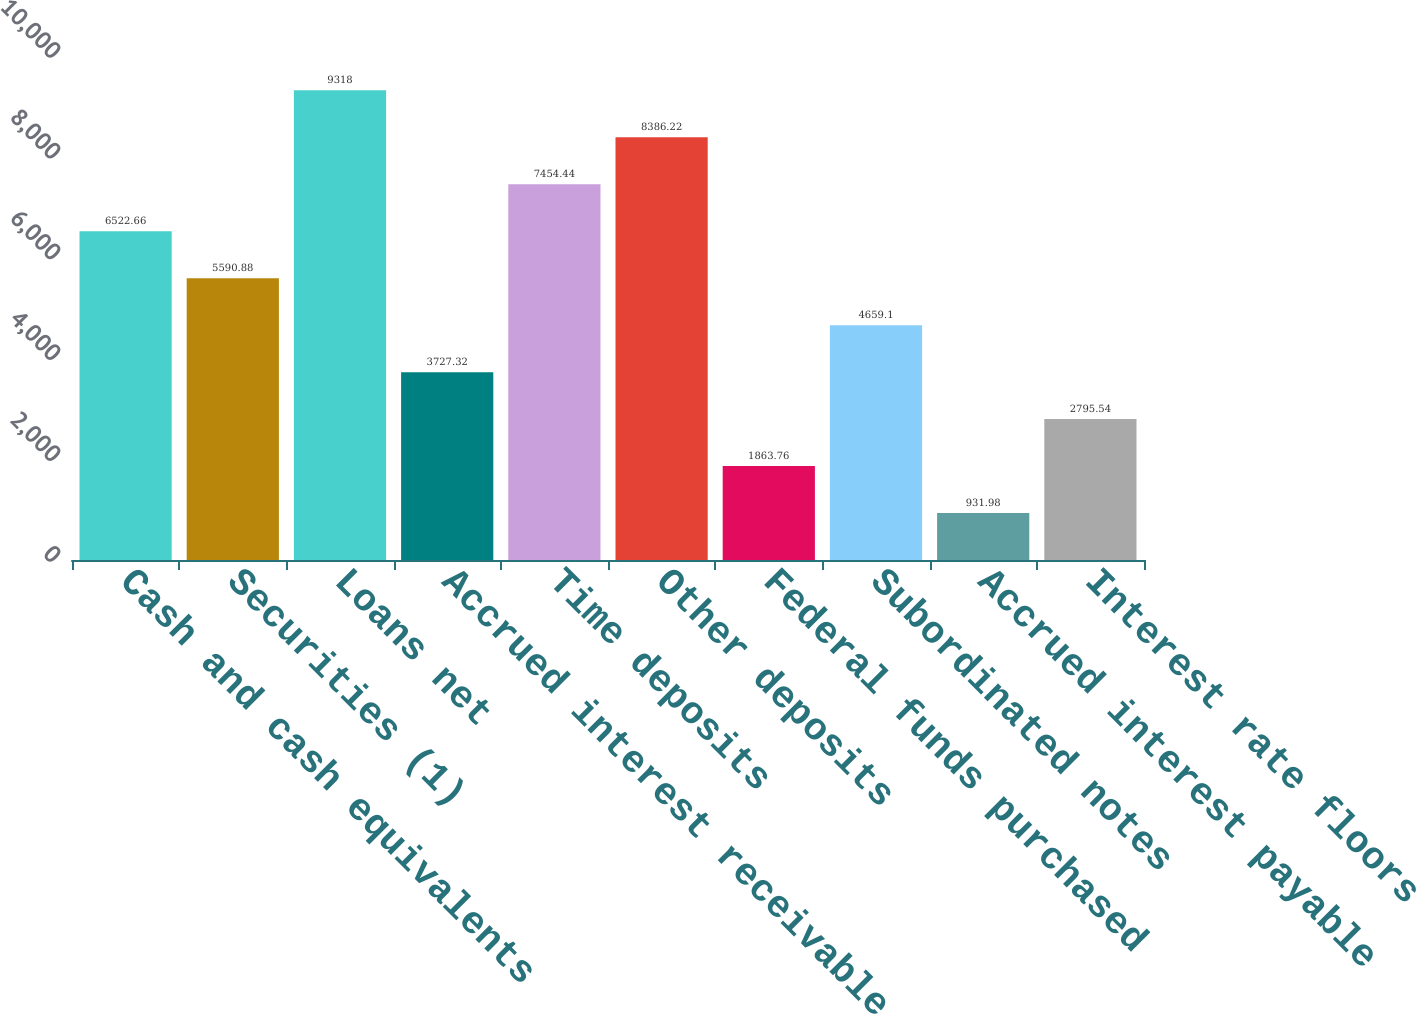Convert chart. <chart><loc_0><loc_0><loc_500><loc_500><bar_chart><fcel>Cash and cash equivalents<fcel>Securities (1)<fcel>Loans net<fcel>Accrued interest receivable<fcel>Time deposits<fcel>Other deposits<fcel>Federal funds purchased<fcel>Subordinated notes<fcel>Accrued interest payable<fcel>Interest rate floors<nl><fcel>6522.66<fcel>5590.88<fcel>9318<fcel>3727.32<fcel>7454.44<fcel>8386.22<fcel>1863.76<fcel>4659.1<fcel>931.98<fcel>2795.54<nl></chart> 